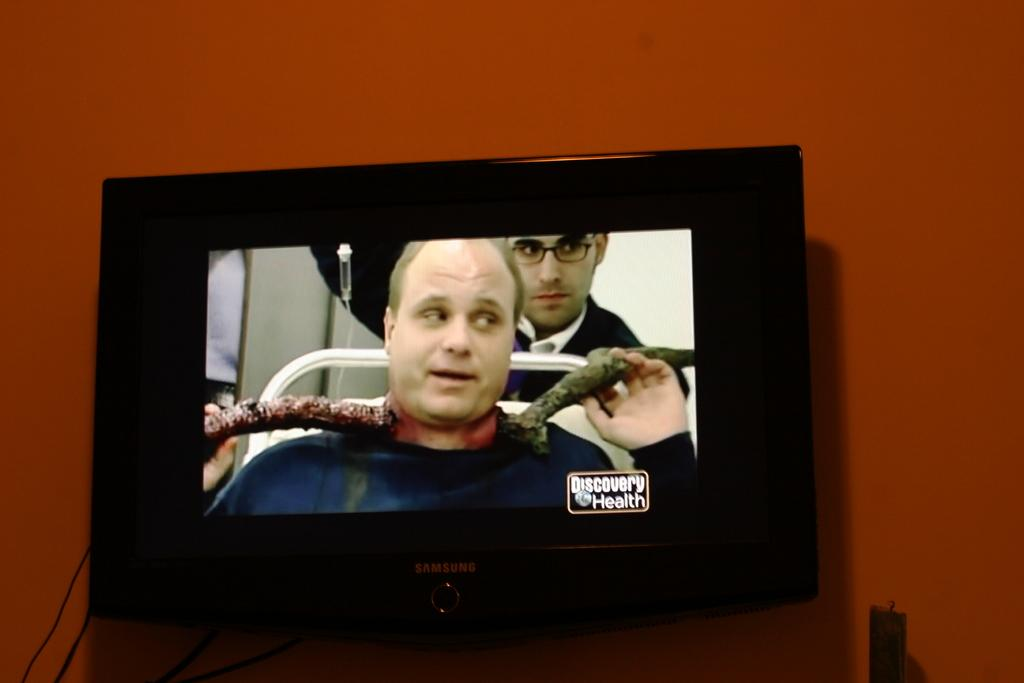<image>
Render a clear and concise summary of the photo. A man has an injury on Discovery Health channel. 